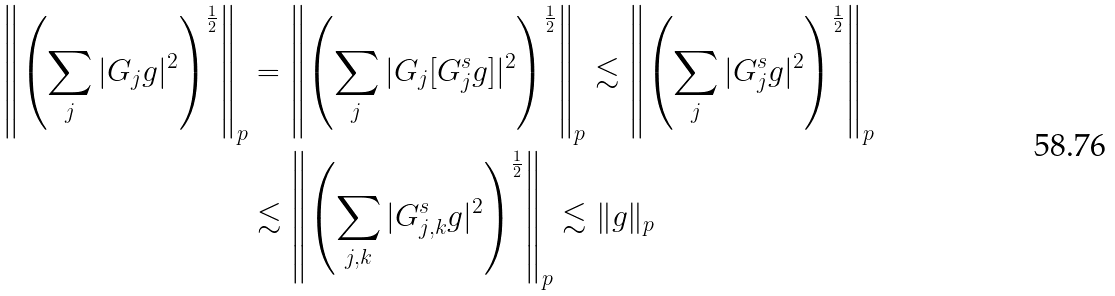Convert formula to latex. <formula><loc_0><loc_0><loc_500><loc_500>\left \| \left ( \sum _ { j } | G _ { j } g | ^ { 2 } \right ) ^ { \frac { 1 } { 2 } } \right \| _ { p } & = \left \| \left ( \sum _ { j } | G _ { j } [ G ^ { s } _ { j } g ] | ^ { 2 } \right ) ^ { \frac { 1 } { 2 } } \right \| _ { p } \lesssim \left \| \left ( \sum _ { j } | G ^ { s } _ { j } g | ^ { 2 } \right ) ^ { \frac { 1 } { 2 } } \right \| _ { p } \\ & \lesssim \left \| \left ( \sum _ { j , k } | G ^ { s } _ { j , k } g | ^ { 2 } \right ) ^ { \frac { 1 } { 2 } } \right \| _ { p } \lesssim \| g \| _ { p }</formula> 